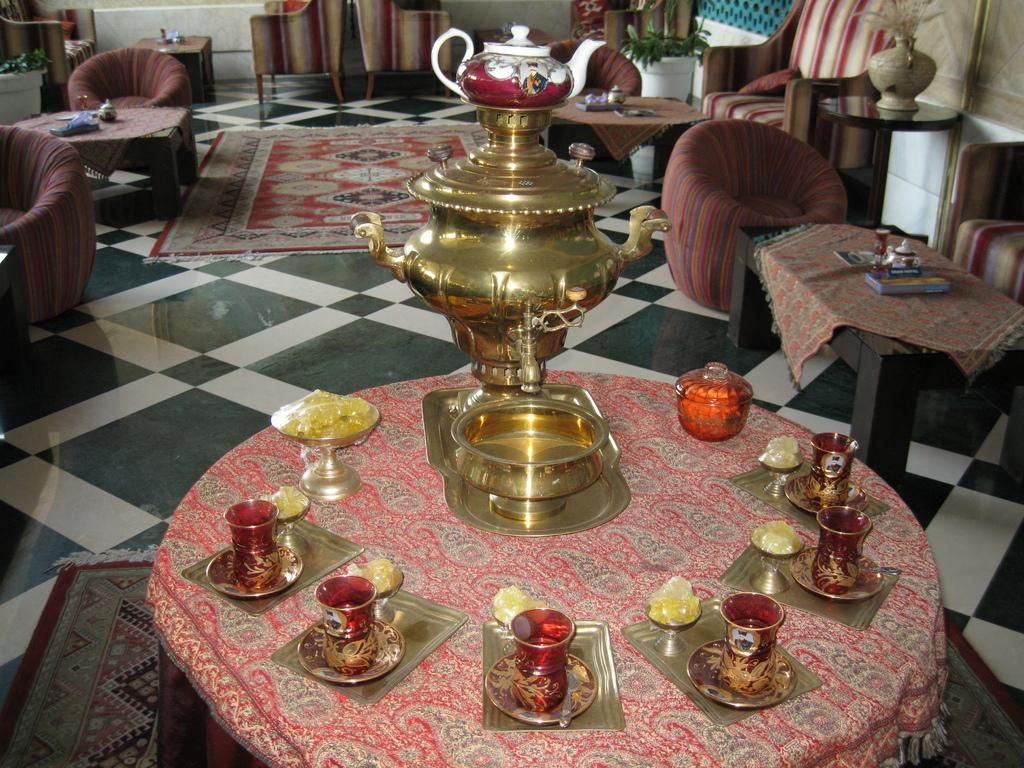What type of tableware can be seen on the table in the image? There are glasses, plates, and bowls on the table in the image. What is the teapot used for? The teapot is used for serving tea or other hot beverages. What type of furniture is visible in the background? In the background, there are couches. What other objects can be seen on the table? There are additional objects on the table, but their specific nature is not mentioned in the provided facts. What type of advice does the doctor give to the grandfather in the image? There is no doctor or grandfather present in the image; it only features a table with tableware, a teapot, and couches in the background. 